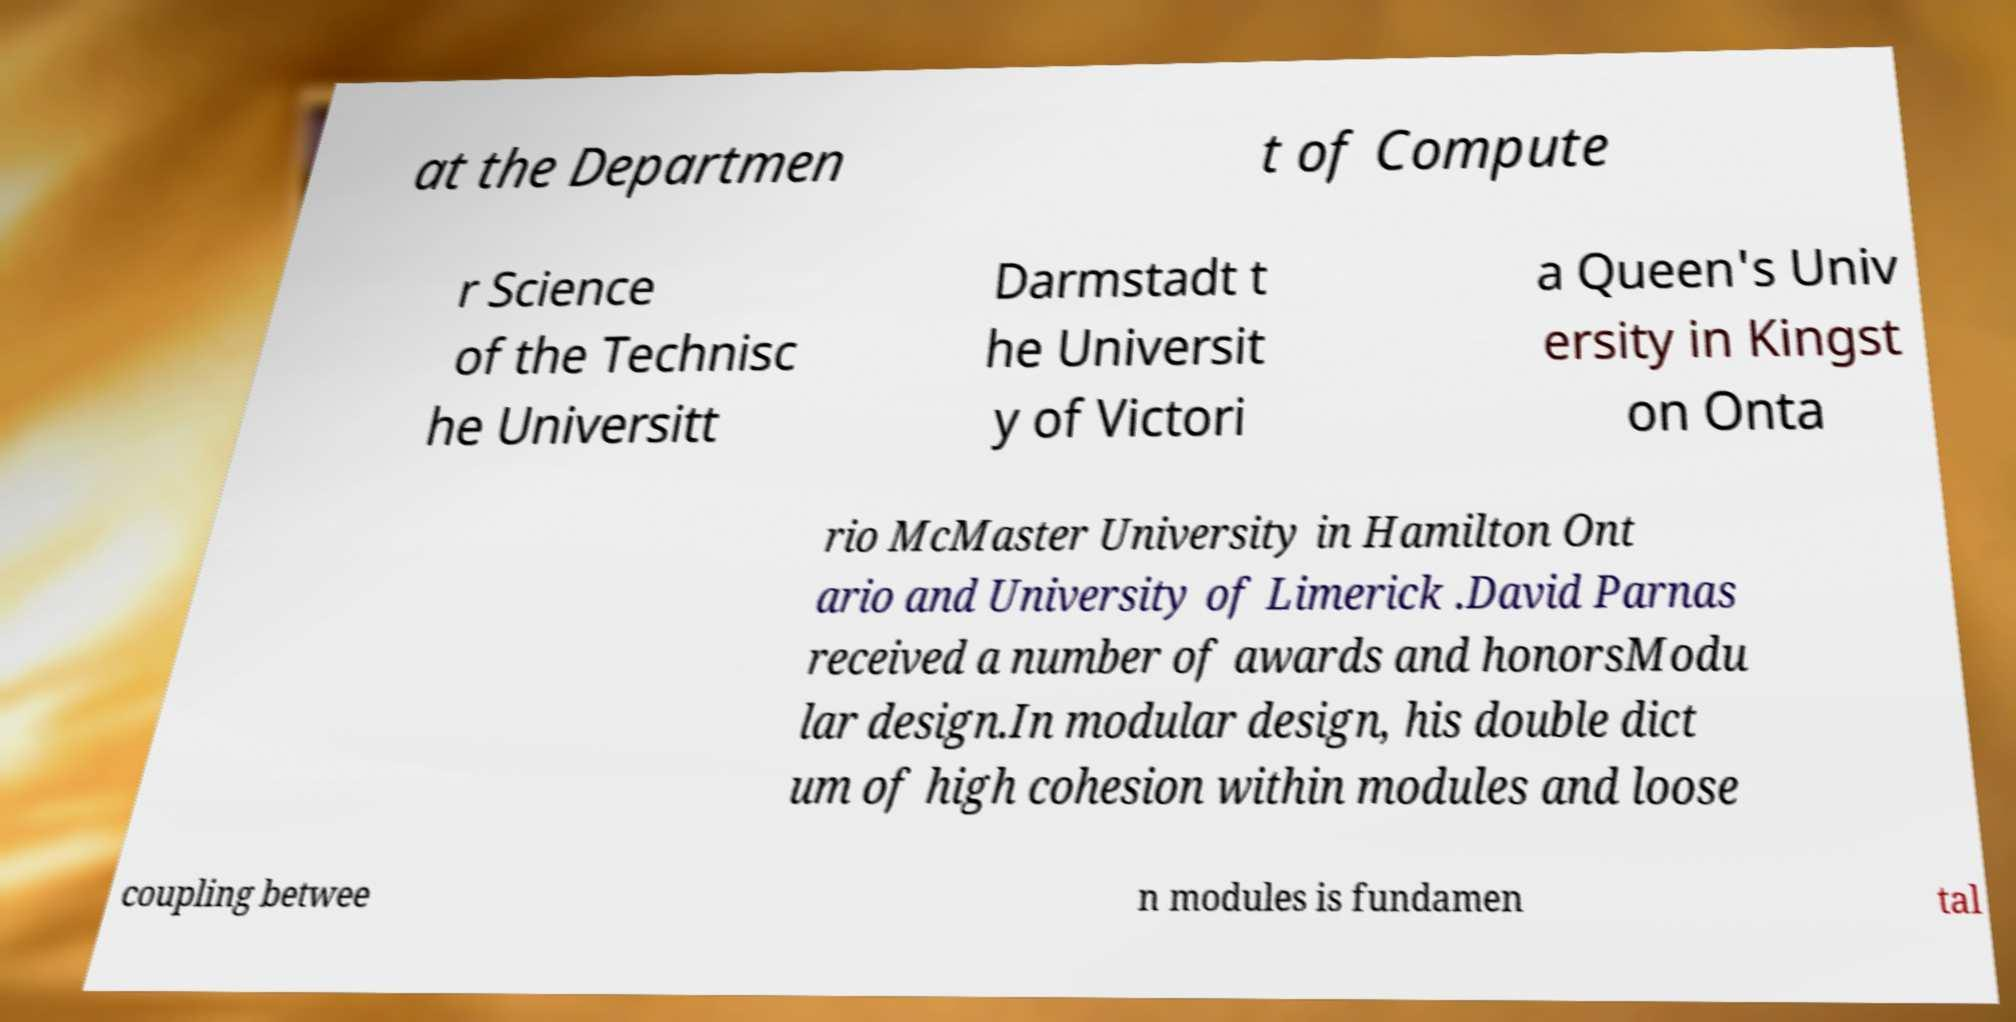Please read and relay the text visible in this image. What does it say? at the Departmen t of Compute r Science of the Technisc he Universitt Darmstadt t he Universit y of Victori a Queen's Univ ersity in Kingst on Onta rio McMaster University in Hamilton Ont ario and University of Limerick .David Parnas received a number of awards and honorsModu lar design.In modular design, his double dict um of high cohesion within modules and loose coupling betwee n modules is fundamen tal 